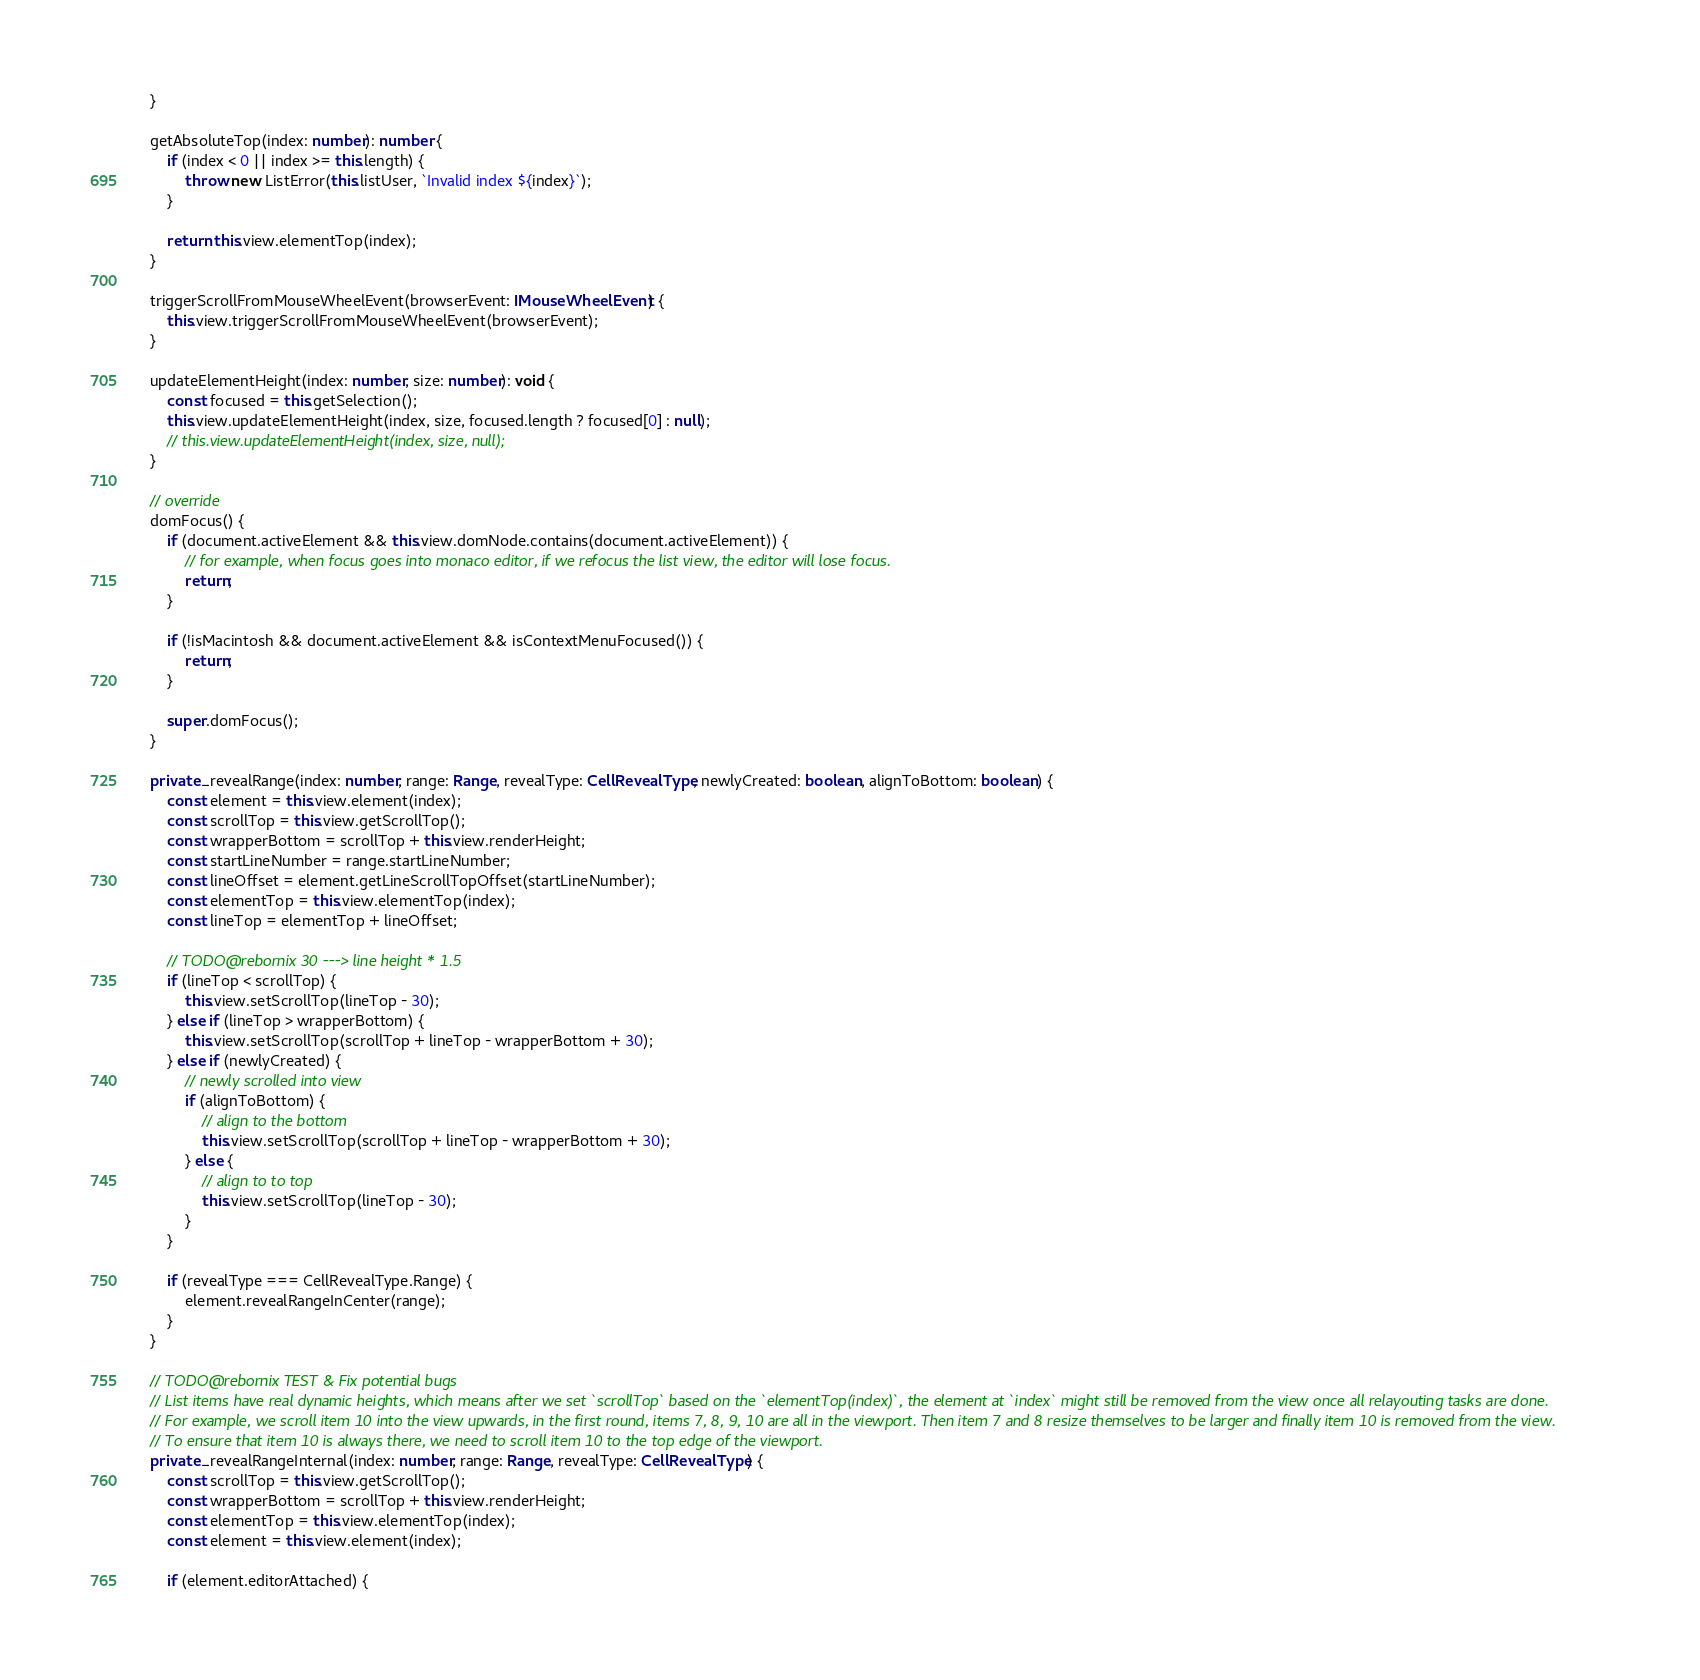Convert code to text. <code><loc_0><loc_0><loc_500><loc_500><_TypeScript_>	}

	getAbsoluteTop(index: number): number {
		if (index < 0 || index >= this.length) {
			throw new ListError(this.listUser, `Invalid index ${index}`);
		}

		return this.view.elementTop(index);
	}

	triggerScrollFromMouseWheelEvent(browserEvent: IMouseWheelEvent) {
		this.view.triggerScrollFromMouseWheelEvent(browserEvent);
	}

	updateElementHeight(index: number, size: number): void {
		const focused = this.getSelection();
		this.view.updateElementHeight(index, size, focused.length ? focused[0] : null);
		// this.view.updateElementHeight(index, size, null);
	}

	// override
	domFocus() {
		if (document.activeElement && this.view.domNode.contains(document.activeElement)) {
			// for example, when focus goes into monaco editor, if we refocus the list view, the editor will lose focus.
			return;
		}

		if (!isMacintosh && document.activeElement && isContextMenuFocused()) {
			return;
		}

		super.domFocus();
	}

	private _revealRange(index: number, range: Range, revealType: CellRevealType, newlyCreated: boolean, alignToBottom: boolean) {
		const element = this.view.element(index);
		const scrollTop = this.view.getScrollTop();
		const wrapperBottom = scrollTop + this.view.renderHeight;
		const startLineNumber = range.startLineNumber;
		const lineOffset = element.getLineScrollTopOffset(startLineNumber);
		const elementTop = this.view.elementTop(index);
		const lineTop = elementTop + lineOffset;

		// TODO@rebornix 30 ---> line height * 1.5
		if (lineTop < scrollTop) {
			this.view.setScrollTop(lineTop - 30);
		} else if (lineTop > wrapperBottom) {
			this.view.setScrollTop(scrollTop + lineTop - wrapperBottom + 30);
		} else if (newlyCreated) {
			// newly scrolled into view
			if (alignToBottom) {
				// align to the bottom
				this.view.setScrollTop(scrollTop + lineTop - wrapperBottom + 30);
			} else {
				// align to to top
				this.view.setScrollTop(lineTop - 30);
			}
		}

		if (revealType === CellRevealType.Range) {
			element.revealRangeInCenter(range);
		}
	}

	// TODO@rebornix TEST & Fix potential bugs
	// List items have real dynamic heights, which means after we set `scrollTop` based on the `elementTop(index)`, the element at `index` might still be removed from the view once all relayouting tasks are done.
	// For example, we scroll item 10 into the view upwards, in the first round, items 7, 8, 9, 10 are all in the viewport. Then item 7 and 8 resize themselves to be larger and finally item 10 is removed from the view.
	// To ensure that item 10 is always there, we need to scroll item 10 to the top edge of the viewport.
	private _revealRangeInternal(index: number, range: Range, revealType: CellRevealType) {
		const scrollTop = this.view.getScrollTop();
		const wrapperBottom = scrollTop + this.view.renderHeight;
		const elementTop = this.view.elementTop(index);
		const element = this.view.element(index);

		if (element.editorAttached) {</code> 